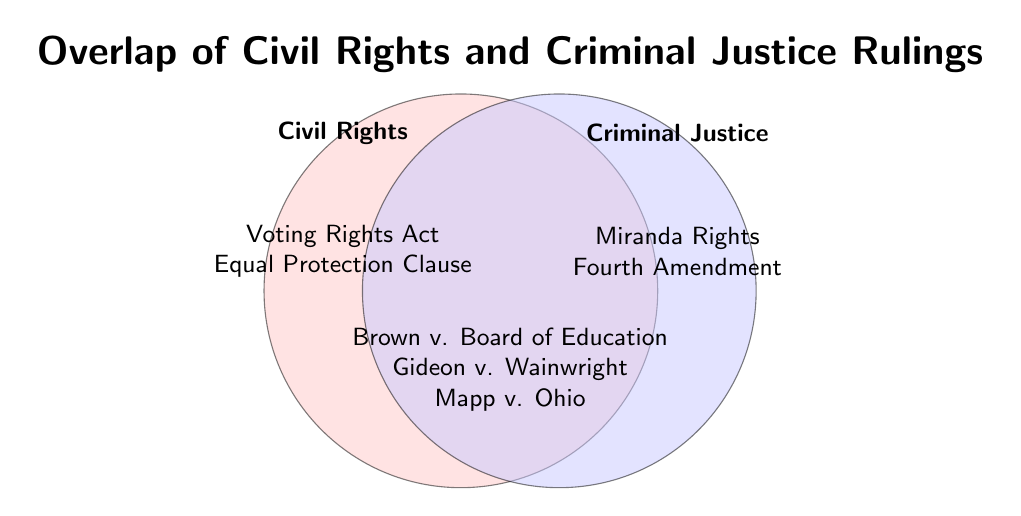What rulings are listed under both Civil Rights and Criminal Justice? The intersecting area of the Venn diagram contains the rulings that fall under both categories. The items listed there are Brown v. Board of Education, Gideon v. Wainwright, and Mapp v. Ohio.
Answer: Brown v. Board of Education, Gideon v. Wainwright, Mapp v. Ohio Which area has more rulings listed, Civil Rights or Criminal Justice? By counting the items in each area that is not overlapping, Civil Rights has two items (Voting Rights Act, Equal Protection Clause) and Criminal Justice also has two items (Miranda Rights, Fourth Amendment). Therefore, both areas have an equal number of rulings listed.
Answer: Equal How many rulings in total are mentioned in the Venn diagram? Add the number of unique items across Civil Rights, Criminal Justice, and Both categories. Civil Rights has 2 items, Criminal Justice has 2 items, and Both has 3 unique items. So, the total is 2 + 2 + 3 = 7.
Answer: 7 Are there more rulings that fall under both categories or under just one category? There are 3 rulings that fall under both categories (Brown v. Board of Education, Gideon v. Wainwright, Mapp v. Ohio) and 4 rulings that fall under just one category (Voting Rights Act, Equal Protection Clause, Miranda Rights, Fourth Amendment). Therefore, there are more rulings under just one category.
Answer: Just one category Which rulings fall under Criminal Justice but not under Civil Rights? The area labeled Criminal Justice only contains the rulings Miranda Rights and Fourth Amendment.
Answer: Miranda Rights, Fourth Amendment 